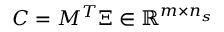<formula> <loc_0><loc_0><loc_500><loc_500>C = M ^ { T } \Xi \in \mathbb { R } ^ { m \times n _ { s } }</formula> 